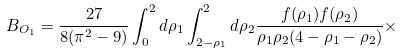Convert formula to latex. <formula><loc_0><loc_0><loc_500><loc_500>B _ { O _ { 1 } } = \frac { 2 7 } { 8 ( \pi ^ { 2 } - 9 ) } \int _ { 0 } ^ { 2 } d \rho _ { 1 } \int _ { 2 - \rho _ { 1 } } ^ { 2 } d \rho _ { 2 } \frac { f ( \rho _ { 1 } ) f ( \rho _ { 2 } ) } { \rho _ { 1 } \rho _ { 2 } ( 4 - \rho _ { 1 } - \rho _ { 2 } ) } \times</formula> 